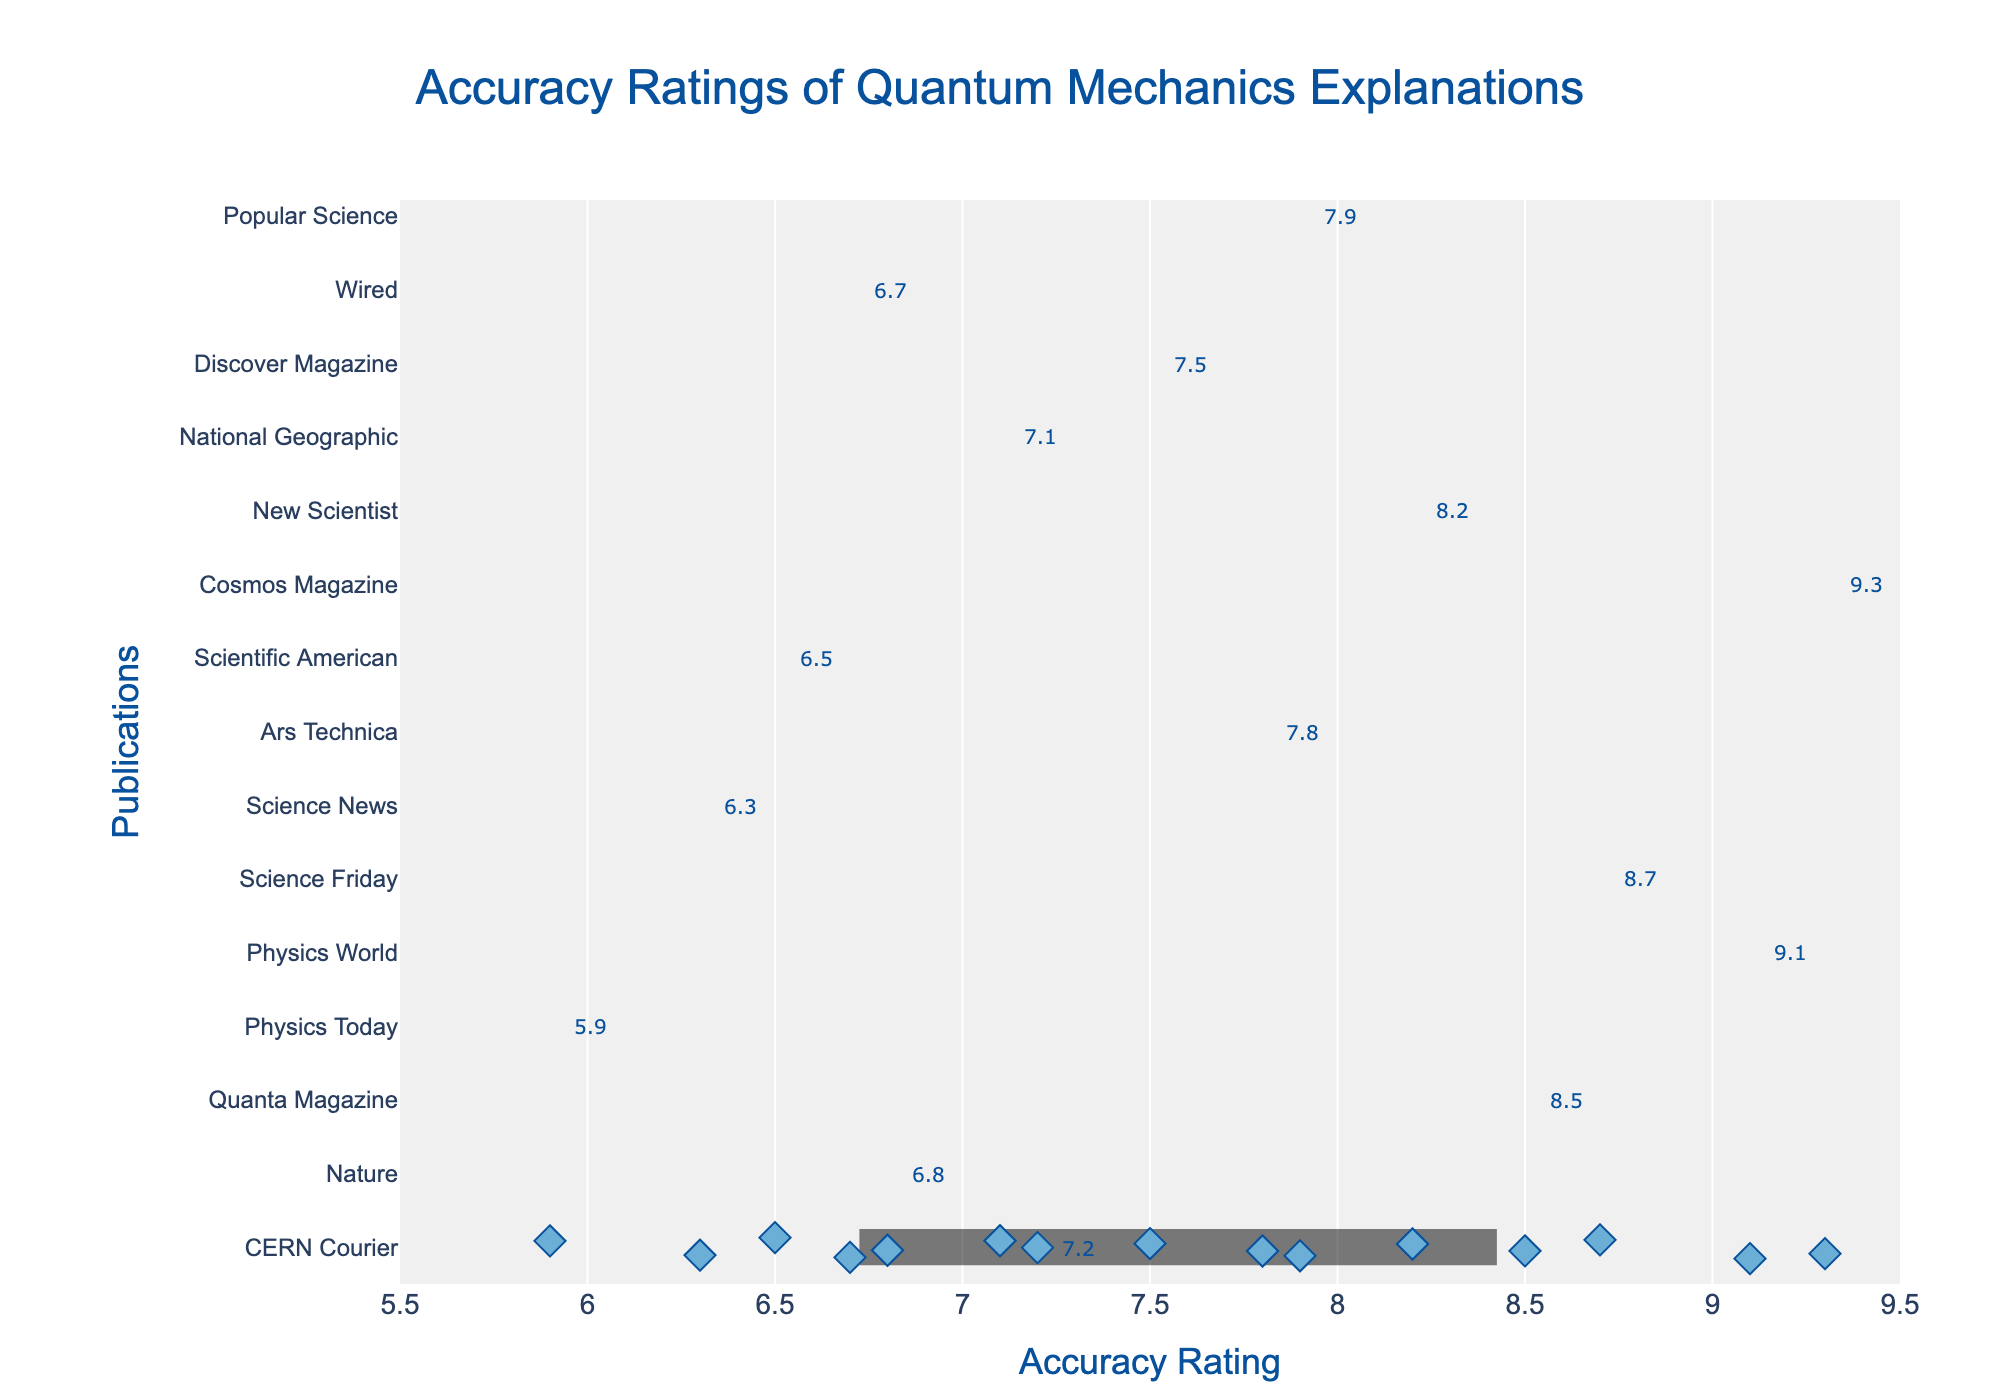What is the title of the figure? The title is displayed prominently at the top of the figure. It reads, "Accuracy Ratings of Quantum Mechanics Explanations".
Answer: Accuracy Ratings of Quantum Mechanics Explanations Which publication has the highest accuracy rating? By looking at the strip plot, we can see that the diamond marker at the highest point is labeled "CERN Courier" with a rating of 9.3.
Answer: CERN Courier How many publications have an accuracy rating above 8? By counting the number of diamond markers labeled above the rating of 8 on the x-axis: Physics Today (8.5), Nature (9.1), Quanta Magazine (8.7), CERN Courier (9.3), Physics World (8.2). There are 5 publications.
Answer: 5 Which publication has a lower accuracy rating: Wired or National Geographic? Comparing the x-axis positions of the markers labeled "Wired" and "National Geographic", Wired is at 6.3 and National Geographic is at 6.7. Wired has a lower rating.
Answer: Wired What's the difference in accuracy rating between the highest and lowest rated publications? The highest rating is 9.3 (CERN Courier) and the lowest is 5.9 (Popular Science). The difference is 9.3 - 5.9 = 3.4.
Answer: 3.4 What is the median accuracy rating of all listed publications? To find the median, we need to sort the ratings and find the middle value. The sorted ratings are [5.9, 6.3, 6.5, 6.7, 6.8, 7.1, 7.2, 7.5, 7.8, 7.9, 8.2, 8.5, 8.7, 9.1, 9.3]. The median is the 8th value, which is 7.5.
Answer: 7.5 Which publication has the closest accuracy rating to 8.0? By examining the diamond markers and their labels around the 8.0 mark, "Science News" with a rating of 7.8 is the closest.
Answer: Science News How many publications have an accuracy rating of less than 7? By counting the number of publications with markers to the left of the 7 on the x-axis: Popular Science (5.9), Wired (6.3), Discover Magazine (6.5), National Geographic (6.7). There are 4 publications.
Answer: 4 What is the overall range of accuracy ratings in the data? The highest rating is 9.3 and the lowest rating is 5.9. The range is 9.3 - 5.9 = 3.4.
Answer: 3.4 